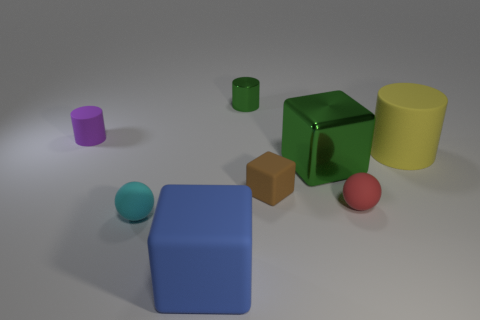Is the purple object the same shape as the small metal object?
Give a very brief answer. Yes. There is a matte cylinder to the right of the big matte thing that is left of the cylinder that is to the right of the tiny red sphere; what size is it?
Offer a terse response. Large. How many other things are the same material as the small red sphere?
Ensure brevity in your answer.  5. What color is the big rubber thing that is in front of the yellow object?
Offer a very short reply. Blue. What material is the large green block right of the cyan matte thing on the left side of the tiny sphere to the right of the small cyan matte thing?
Offer a very short reply. Metal. Is there a cyan object that has the same shape as the tiny green thing?
Give a very brief answer. No. There is a green metal thing that is the same size as the yellow thing; what is its shape?
Ensure brevity in your answer.  Cube. What number of small matte objects are both behind the brown block and on the right side of the cyan thing?
Offer a very short reply. 0. Are there fewer tiny green metallic things that are to the right of the small green metallic object than small purple matte balls?
Provide a short and direct response. No. Are there any brown cubes that have the same size as the purple cylinder?
Ensure brevity in your answer.  Yes. 